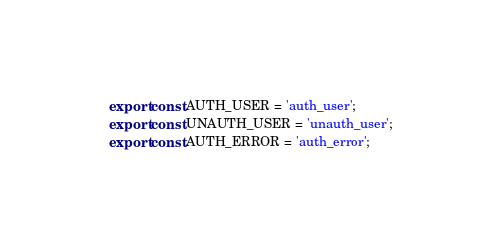Convert code to text. <code><loc_0><loc_0><loc_500><loc_500><_JavaScript_>export const AUTH_USER = 'auth_user';
export const UNAUTH_USER = 'unauth_user';
export const AUTH_ERROR = 'auth_error';
</code> 